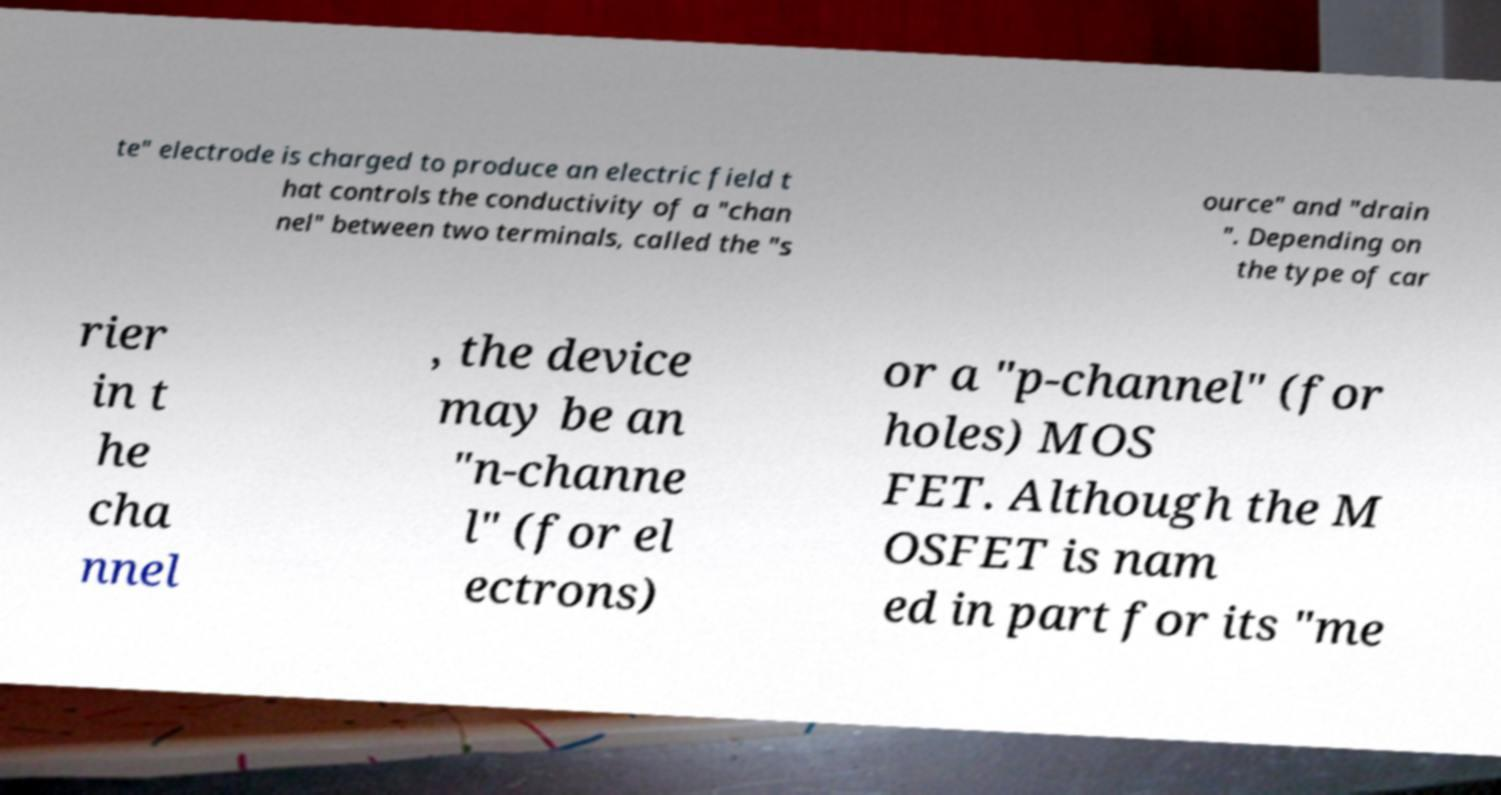Can you read and provide the text displayed in the image?This photo seems to have some interesting text. Can you extract and type it out for me? te" electrode is charged to produce an electric field t hat controls the conductivity of a "chan nel" between two terminals, called the "s ource" and "drain ". Depending on the type of car rier in t he cha nnel , the device may be an "n-channe l" (for el ectrons) or a "p-channel" (for holes) MOS FET. Although the M OSFET is nam ed in part for its "me 